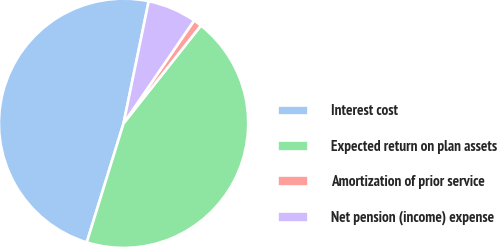Convert chart to OTSL. <chart><loc_0><loc_0><loc_500><loc_500><pie_chart><fcel>Interest cost<fcel>Expected return on plan assets<fcel>Amortization of prior service<fcel>Net pension (income) expense<nl><fcel>48.46%<fcel>44.12%<fcel>1.08%<fcel>6.34%<nl></chart> 